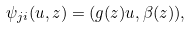Convert formula to latex. <formula><loc_0><loc_0><loc_500><loc_500>\psi _ { j i } ( u , z ) = ( g ( z ) u , \beta ( z ) ) ,</formula> 